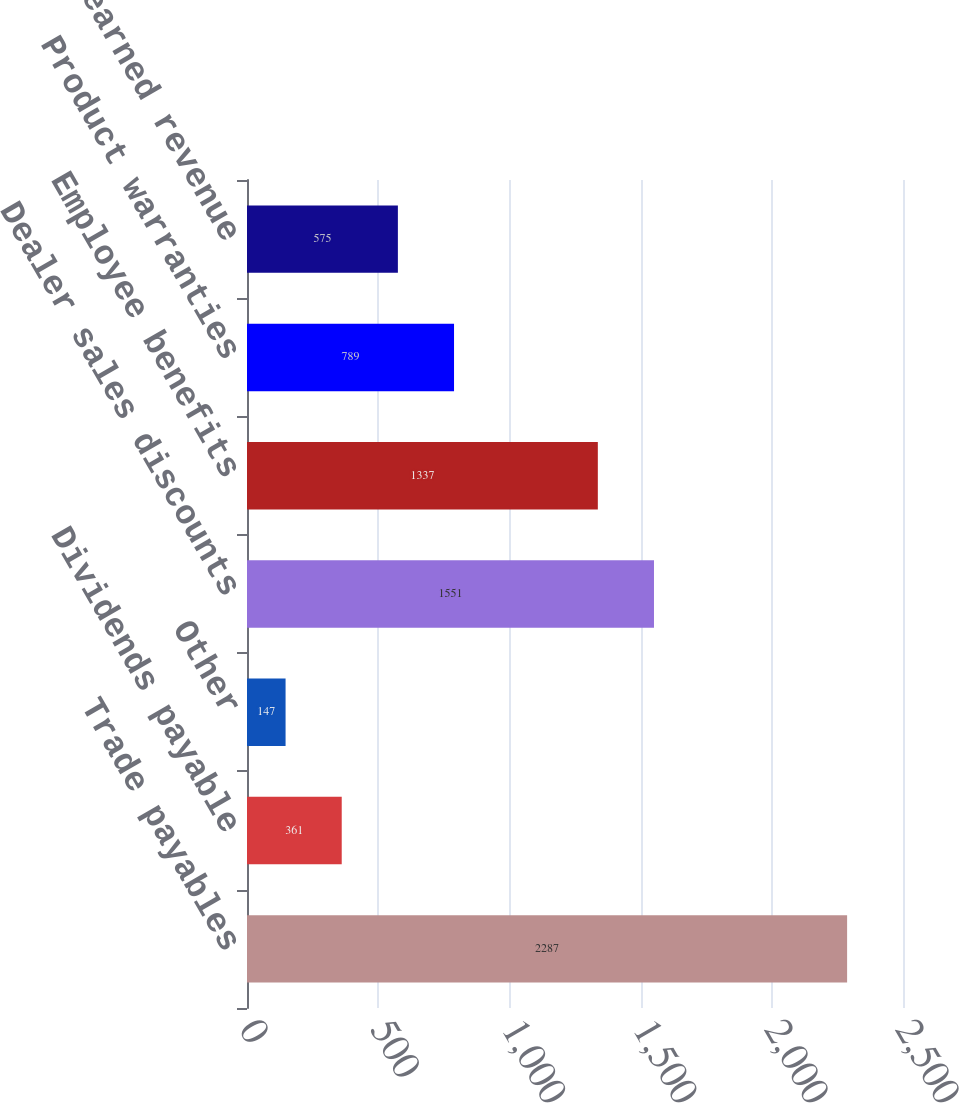Convert chart to OTSL. <chart><loc_0><loc_0><loc_500><loc_500><bar_chart><fcel>Trade payables<fcel>Dividends payable<fcel>Other<fcel>Dealer sales discounts<fcel>Employee benefits<fcel>Product warranties<fcel>Unearned revenue<nl><fcel>2287<fcel>361<fcel>147<fcel>1551<fcel>1337<fcel>789<fcel>575<nl></chart> 